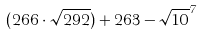Convert formula to latex. <formula><loc_0><loc_0><loc_500><loc_500>( 2 6 6 \cdot \sqrt { 2 9 2 } ) + 2 6 3 - \sqrt { 1 0 } ^ { 7 }</formula> 